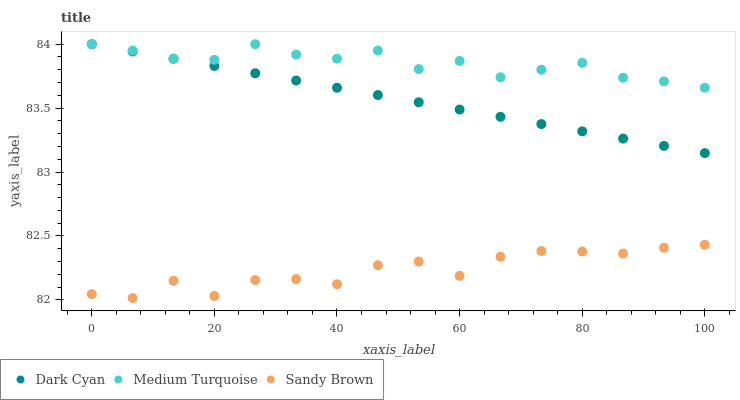Does Sandy Brown have the minimum area under the curve?
Answer yes or no. Yes. Does Medium Turquoise have the maximum area under the curve?
Answer yes or no. Yes. Does Medium Turquoise have the minimum area under the curve?
Answer yes or no. No. Does Sandy Brown have the maximum area under the curve?
Answer yes or no. No. Is Dark Cyan the smoothest?
Answer yes or no. Yes. Is Sandy Brown the roughest?
Answer yes or no. Yes. Is Medium Turquoise the smoothest?
Answer yes or no. No. Is Medium Turquoise the roughest?
Answer yes or no. No. Does Sandy Brown have the lowest value?
Answer yes or no. Yes. Does Medium Turquoise have the lowest value?
Answer yes or no. No. Does Medium Turquoise have the highest value?
Answer yes or no. Yes. Does Sandy Brown have the highest value?
Answer yes or no. No. Is Sandy Brown less than Medium Turquoise?
Answer yes or no. Yes. Is Medium Turquoise greater than Sandy Brown?
Answer yes or no. Yes. Does Dark Cyan intersect Medium Turquoise?
Answer yes or no. Yes. Is Dark Cyan less than Medium Turquoise?
Answer yes or no. No. Is Dark Cyan greater than Medium Turquoise?
Answer yes or no. No. Does Sandy Brown intersect Medium Turquoise?
Answer yes or no. No. 